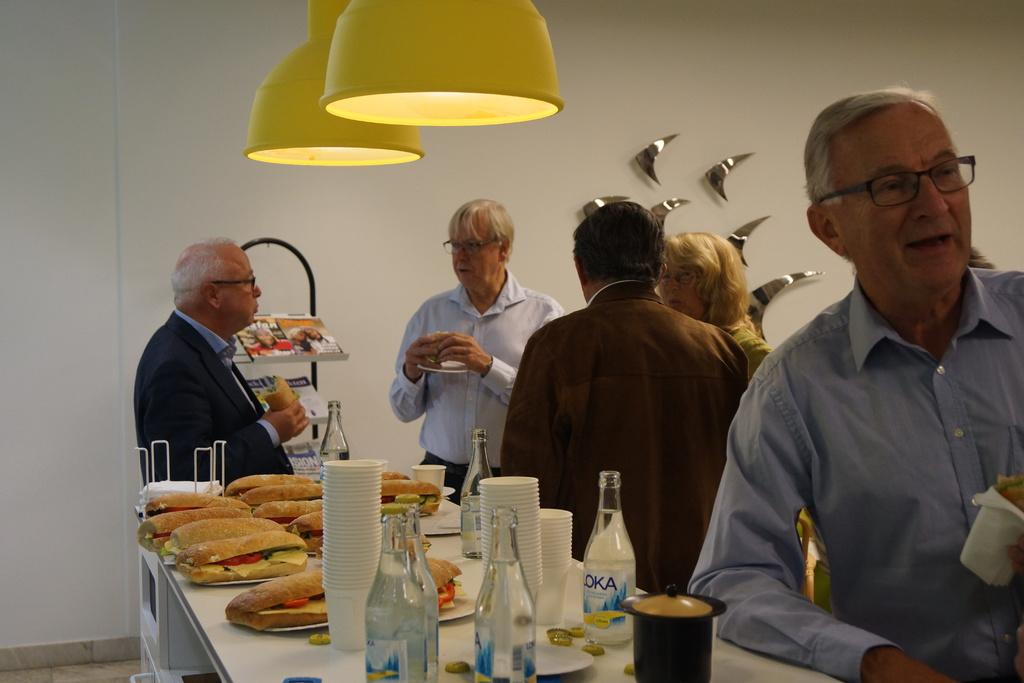What are the people in the image doing? The people in the image are standing behind a table. What is on the table in the image? Food is served on plates on the table, and there are also bottles and glasses. Can you describe the lighting in the image? There is a light hanging from the top, which provides illumination. How many hens are present on the table in the image? There are no hens present on the table in the image. What type of feet can be seen walking around the table in the image? There are no feet visible in the image, as it is focused on the table and its contents. 